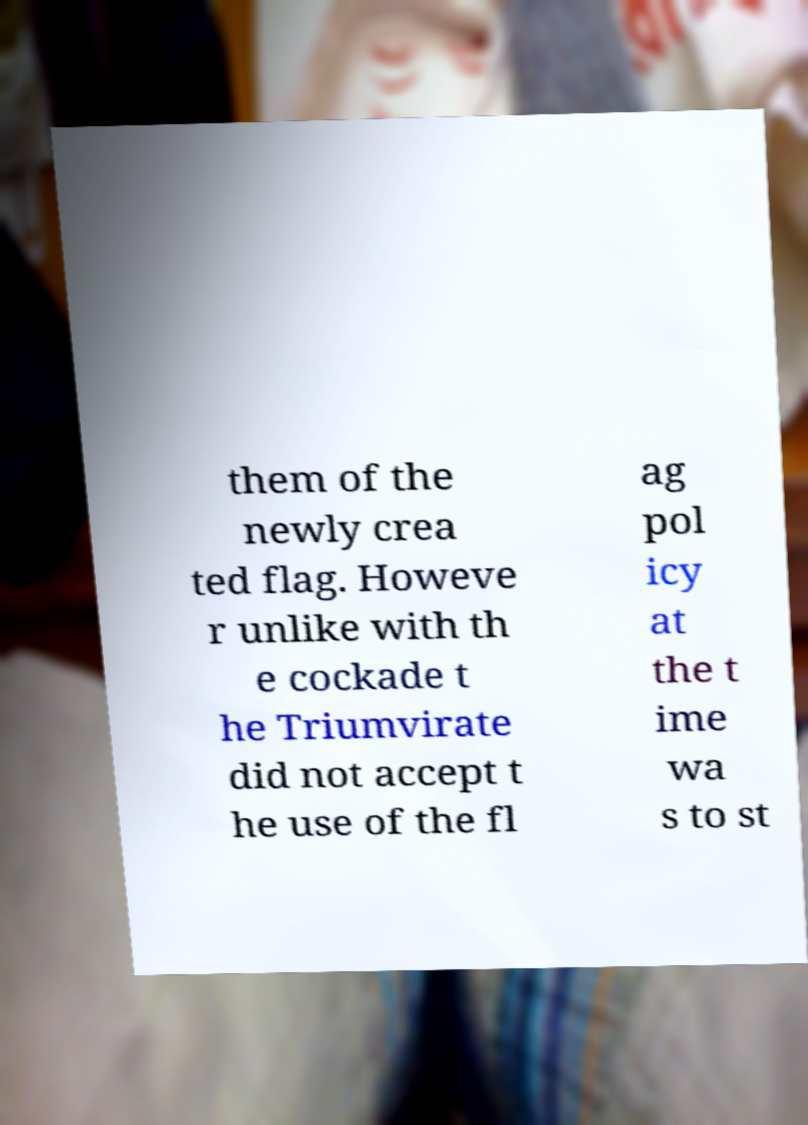Could you extract and type out the text from this image? them of the newly crea ted flag. Howeve r unlike with th e cockade t he Triumvirate did not accept t he use of the fl ag pol icy at the t ime wa s to st 